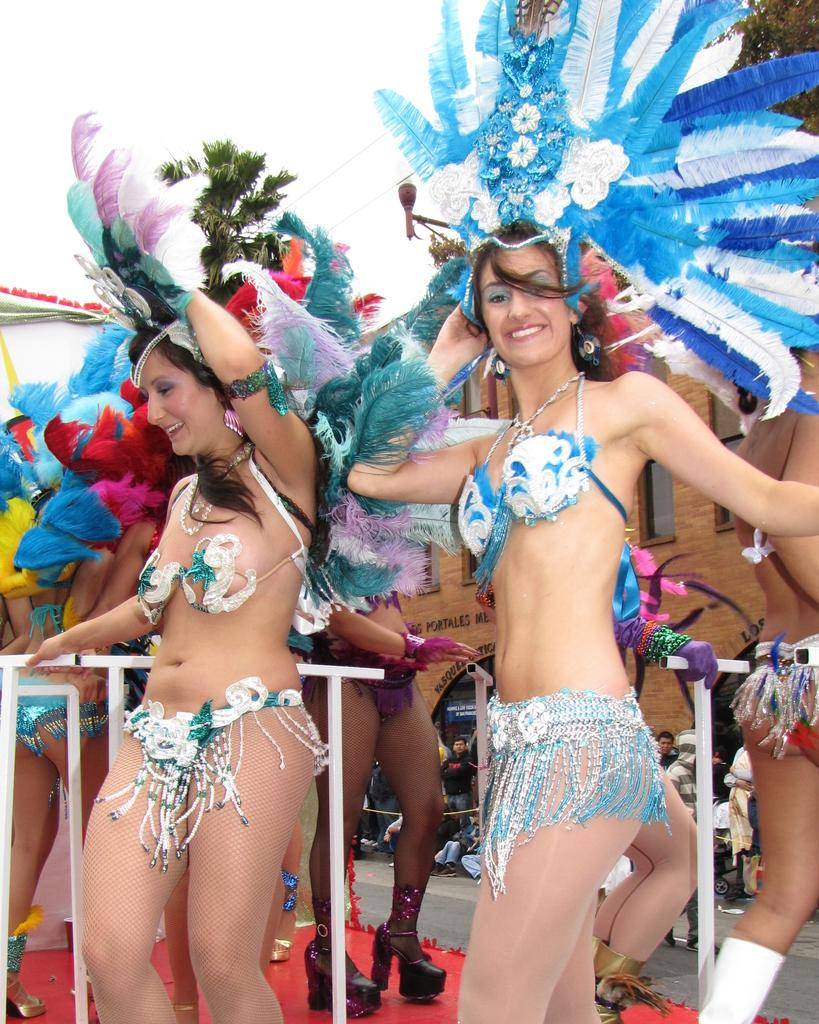What are the people in the image doing? The people in the image are standing and smiling. What is located behind the people? There is a fencing behind the people. What type of vegetation can be seen at the top of the image? Trees are visible at the top of the image. What is visible behind the trees? The sky is visible behind the trees. How many sponges can be seen in the image? There are no sponges present in the image. What type of cattle is visible in the image? There is no cattle present in the image. 